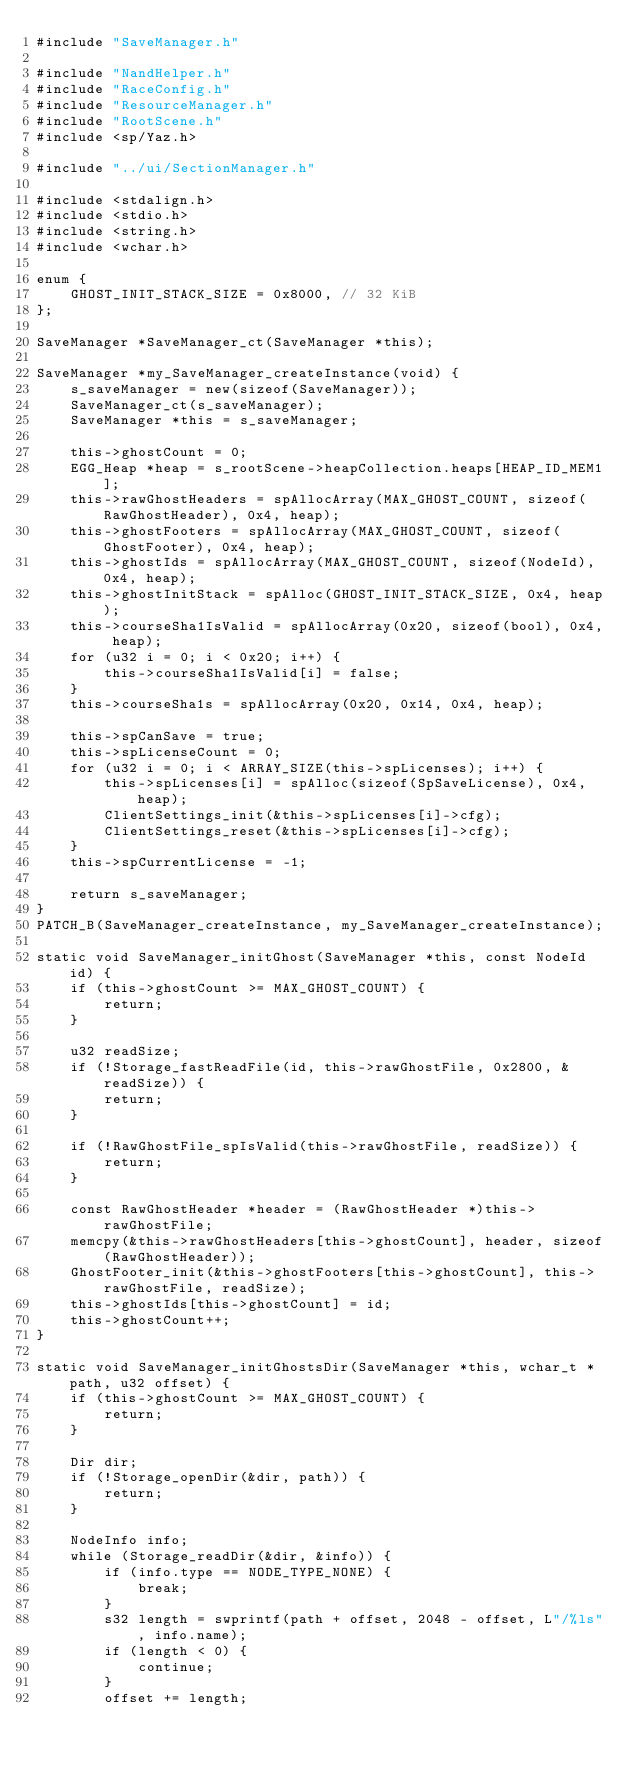Convert code to text. <code><loc_0><loc_0><loc_500><loc_500><_C_>#include "SaveManager.h"

#include "NandHelper.h"
#include "RaceConfig.h"
#include "ResourceManager.h"
#include "RootScene.h"
#include <sp/Yaz.h>

#include "../ui/SectionManager.h"

#include <stdalign.h>
#include <stdio.h>
#include <string.h>
#include <wchar.h>

enum {
    GHOST_INIT_STACK_SIZE = 0x8000, // 32 KiB
};

SaveManager *SaveManager_ct(SaveManager *this);

SaveManager *my_SaveManager_createInstance(void) {
    s_saveManager = new(sizeof(SaveManager));
    SaveManager_ct(s_saveManager);
    SaveManager *this = s_saveManager;

    this->ghostCount = 0;
    EGG_Heap *heap = s_rootScene->heapCollection.heaps[HEAP_ID_MEM1];
    this->rawGhostHeaders = spAllocArray(MAX_GHOST_COUNT, sizeof(RawGhostHeader), 0x4, heap);
    this->ghostFooters = spAllocArray(MAX_GHOST_COUNT, sizeof(GhostFooter), 0x4, heap);
    this->ghostIds = spAllocArray(MAX_GHOST_COUNT, sizeof(NodeId), 0x4, heap);
    this->ghostInitStack = spAlloc(GHOST_INIT_STACK_SIZE, 0x4, heap);
    this->courseSha1IsValid = spAllocArray(0x20, sizeof(bool), 0x4, heap);
    for (u32 i = 0; i < 0x20; i++) {
        this->courseSha1IsValid[i] = false;
    }
    this->courseSha1s = spAllocArray(0x20, 0x14, 0x4, heap);

    this->spCanSave = true;
    this->spLicenseCount = 0;
    for (u32 i = 0; i < ARRAY_SIZE(this->spLicenses); i++) {
        this->spLicenses[i] = spAlloc(sizeof(SpSaveLicense), 0x4, heap);
        ClientSettings_init(&this->spLicenses[i]->cfg);
        ClientSettings_reset(&this->spLicenses[i]->cfg);
    }
    this->spCurrentLicense = -1;

    return s_saveManager;
}
PATCH_B(SaveManager_createInstance, my_SaveManager_createInstance);

static void SaveManager_initGhost(SaveManager *this, const NodeId id) {
    if (this->ghostCount >= MAX_GHOST_COUNT) {
        return;
    }

    u32 readSize;
    if (!Storage_fastReadFile(id, this->rawGhostFile, 0x2800, &readSize)) {
        return;
    }

    if (!RawGhostFile_spIsValid(this->rawGhostFile, readSize)) {
        return;
    }

    const RawGhostHeader *header = (RawGhostHeader *)this->rawGhostFile;
    memcpy(&this->rawGhostHeaders[this->ghostCount], header, sizeof(RawGhostHeader));
    GhostFooter_init(&this->ghostFooters[this->ghostCount], this->rawGhostFile, readSize);
    this->ghostIds[this->ghostCount] = id;
    this->ghostCount++;
}

static void SaveManager_initGhostsDir(SaveManager *this, wchar_t *path, u32 offset) {
    if (this->ghostCount >= MAX_GHOST_COUNT) {
        return;
    }

    Dir dir;
    if (!Storage_openDir(&dir, path)) {
        return;
    }

    NodeInfo info;
    while (Storage_readDir(&dir, &info)) {
        if (info.type == NODE_TYPE_NONE) {
            break;
        }
        s32 length = swprintf(path + offset, 2048 - offset, L"/%ls", info.name);
        if (length < 0) {
            continue;
        }
        offset += length;</code> 